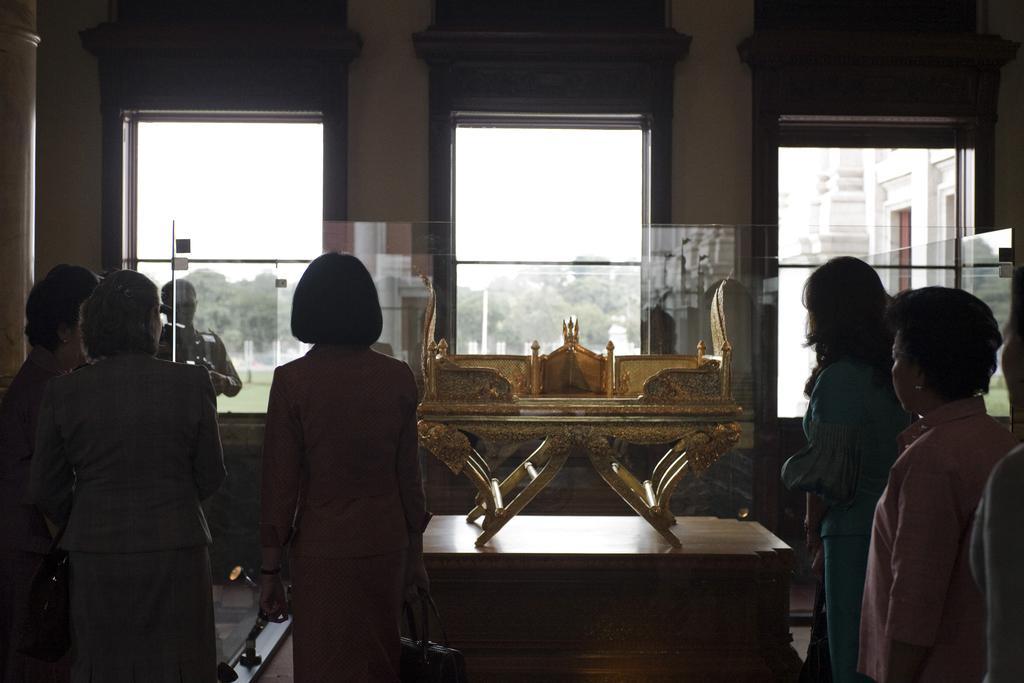How would you summarize this image in a sentence or two? Here we can see some persons are standing on the floor. This is table and there are windows. From the windows we can see some trees and this is sky. 